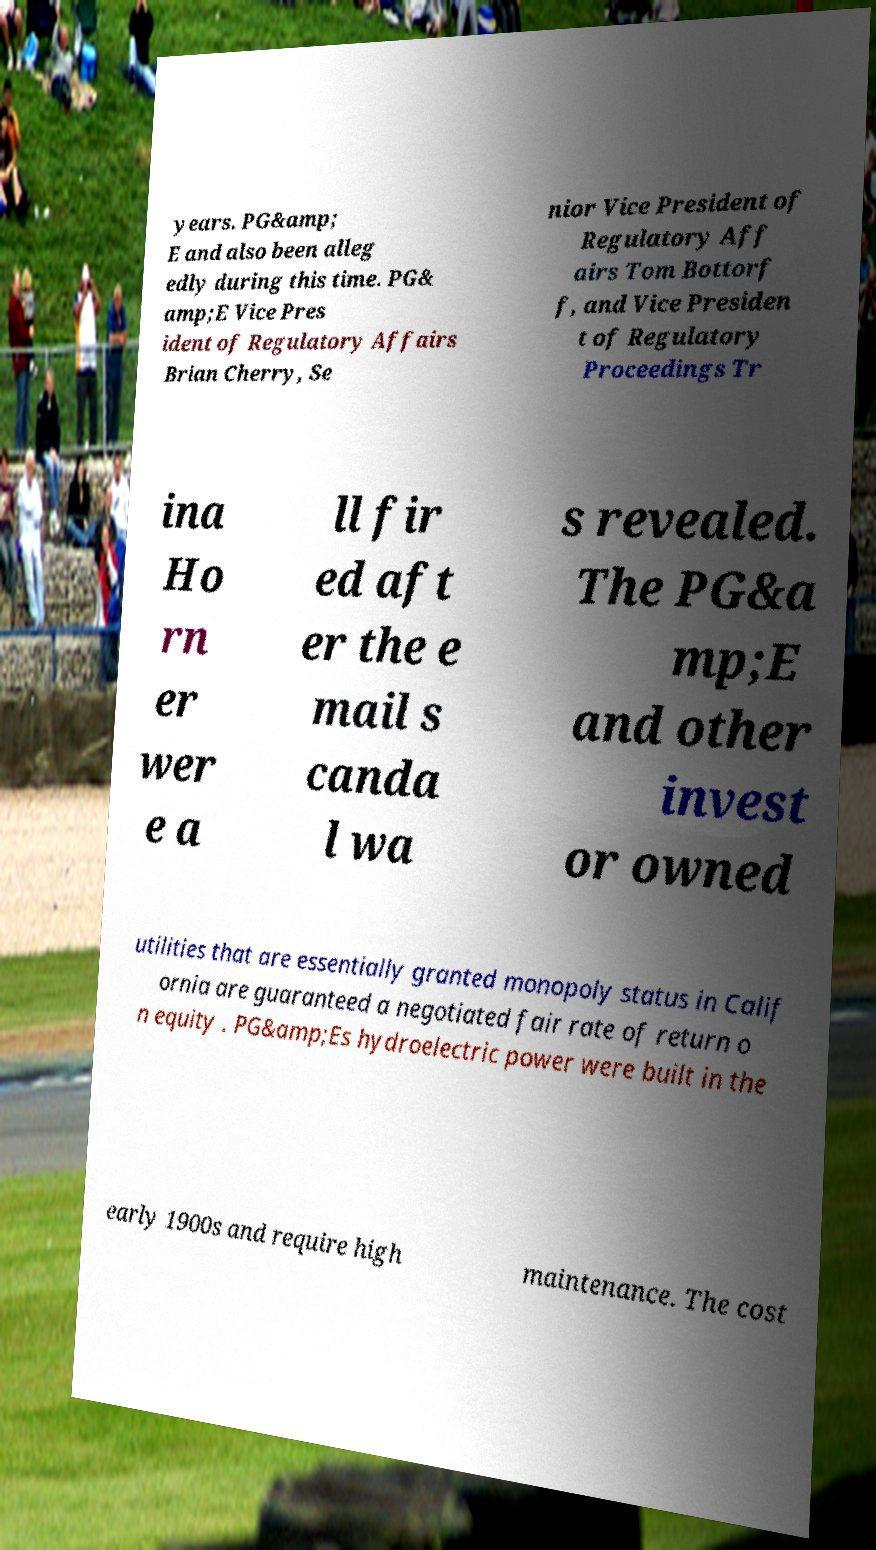For documentation purposes, I need the text within this image transcribed. Could you provide that? years. PG&amp; E and also been alleg edly during this time. PG& amp;E Vice Pres ident of Regulatory Affairs Brian Cherry, Se nior Vice President of Regulatory Aff airs Tom Bottorf f, and Vice Presiden t of Regulatory Proceedings Tr ina Ho rn er wer e a ll fir ed aft er the e mail s canda l wa s revealed. The PG&a mp;E and other invest or owned utilities that are essentially granted monopoly status in Calif ornia are guaranteed a negotiated fair rate of return o n equity . PG&amp;Es hydroelectric power were built in the early 1900s and require high maintenance. The cost 